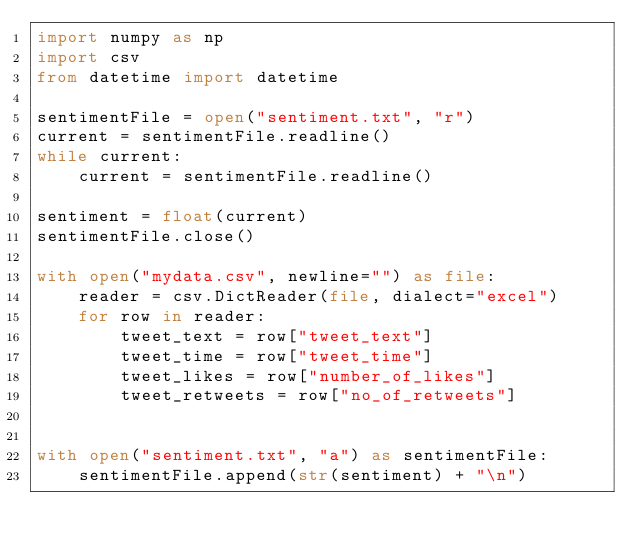Convert code to text. <code><loc_0><loc_0><loc_500><loc_500><_Python_>import numpy as np
import csv
from datetime import datetime

sentimentFile = open("sentiment.txt", "r")
current = sentimentFile.readline()
while current:
    current = sentimentFile.readline()   

sentiment = float(current)
sentimentFile.close()

with open("mydata.csv", newline="") as file:
    reader = csv.DictReader(file, dialect="excel")
    for row in reader:
        tweet_text = row["tweet_text"]
        tweet_time = row["tweet_time"]
        tweet_likes = row["number_of_likes"]
        tweet_retweets = row["no_of_retweets"]


with open("sentiment.txt", "a") as sentimentFile:
    sentimentFile.append(str(sentiment) + "\n")
    



</code> 